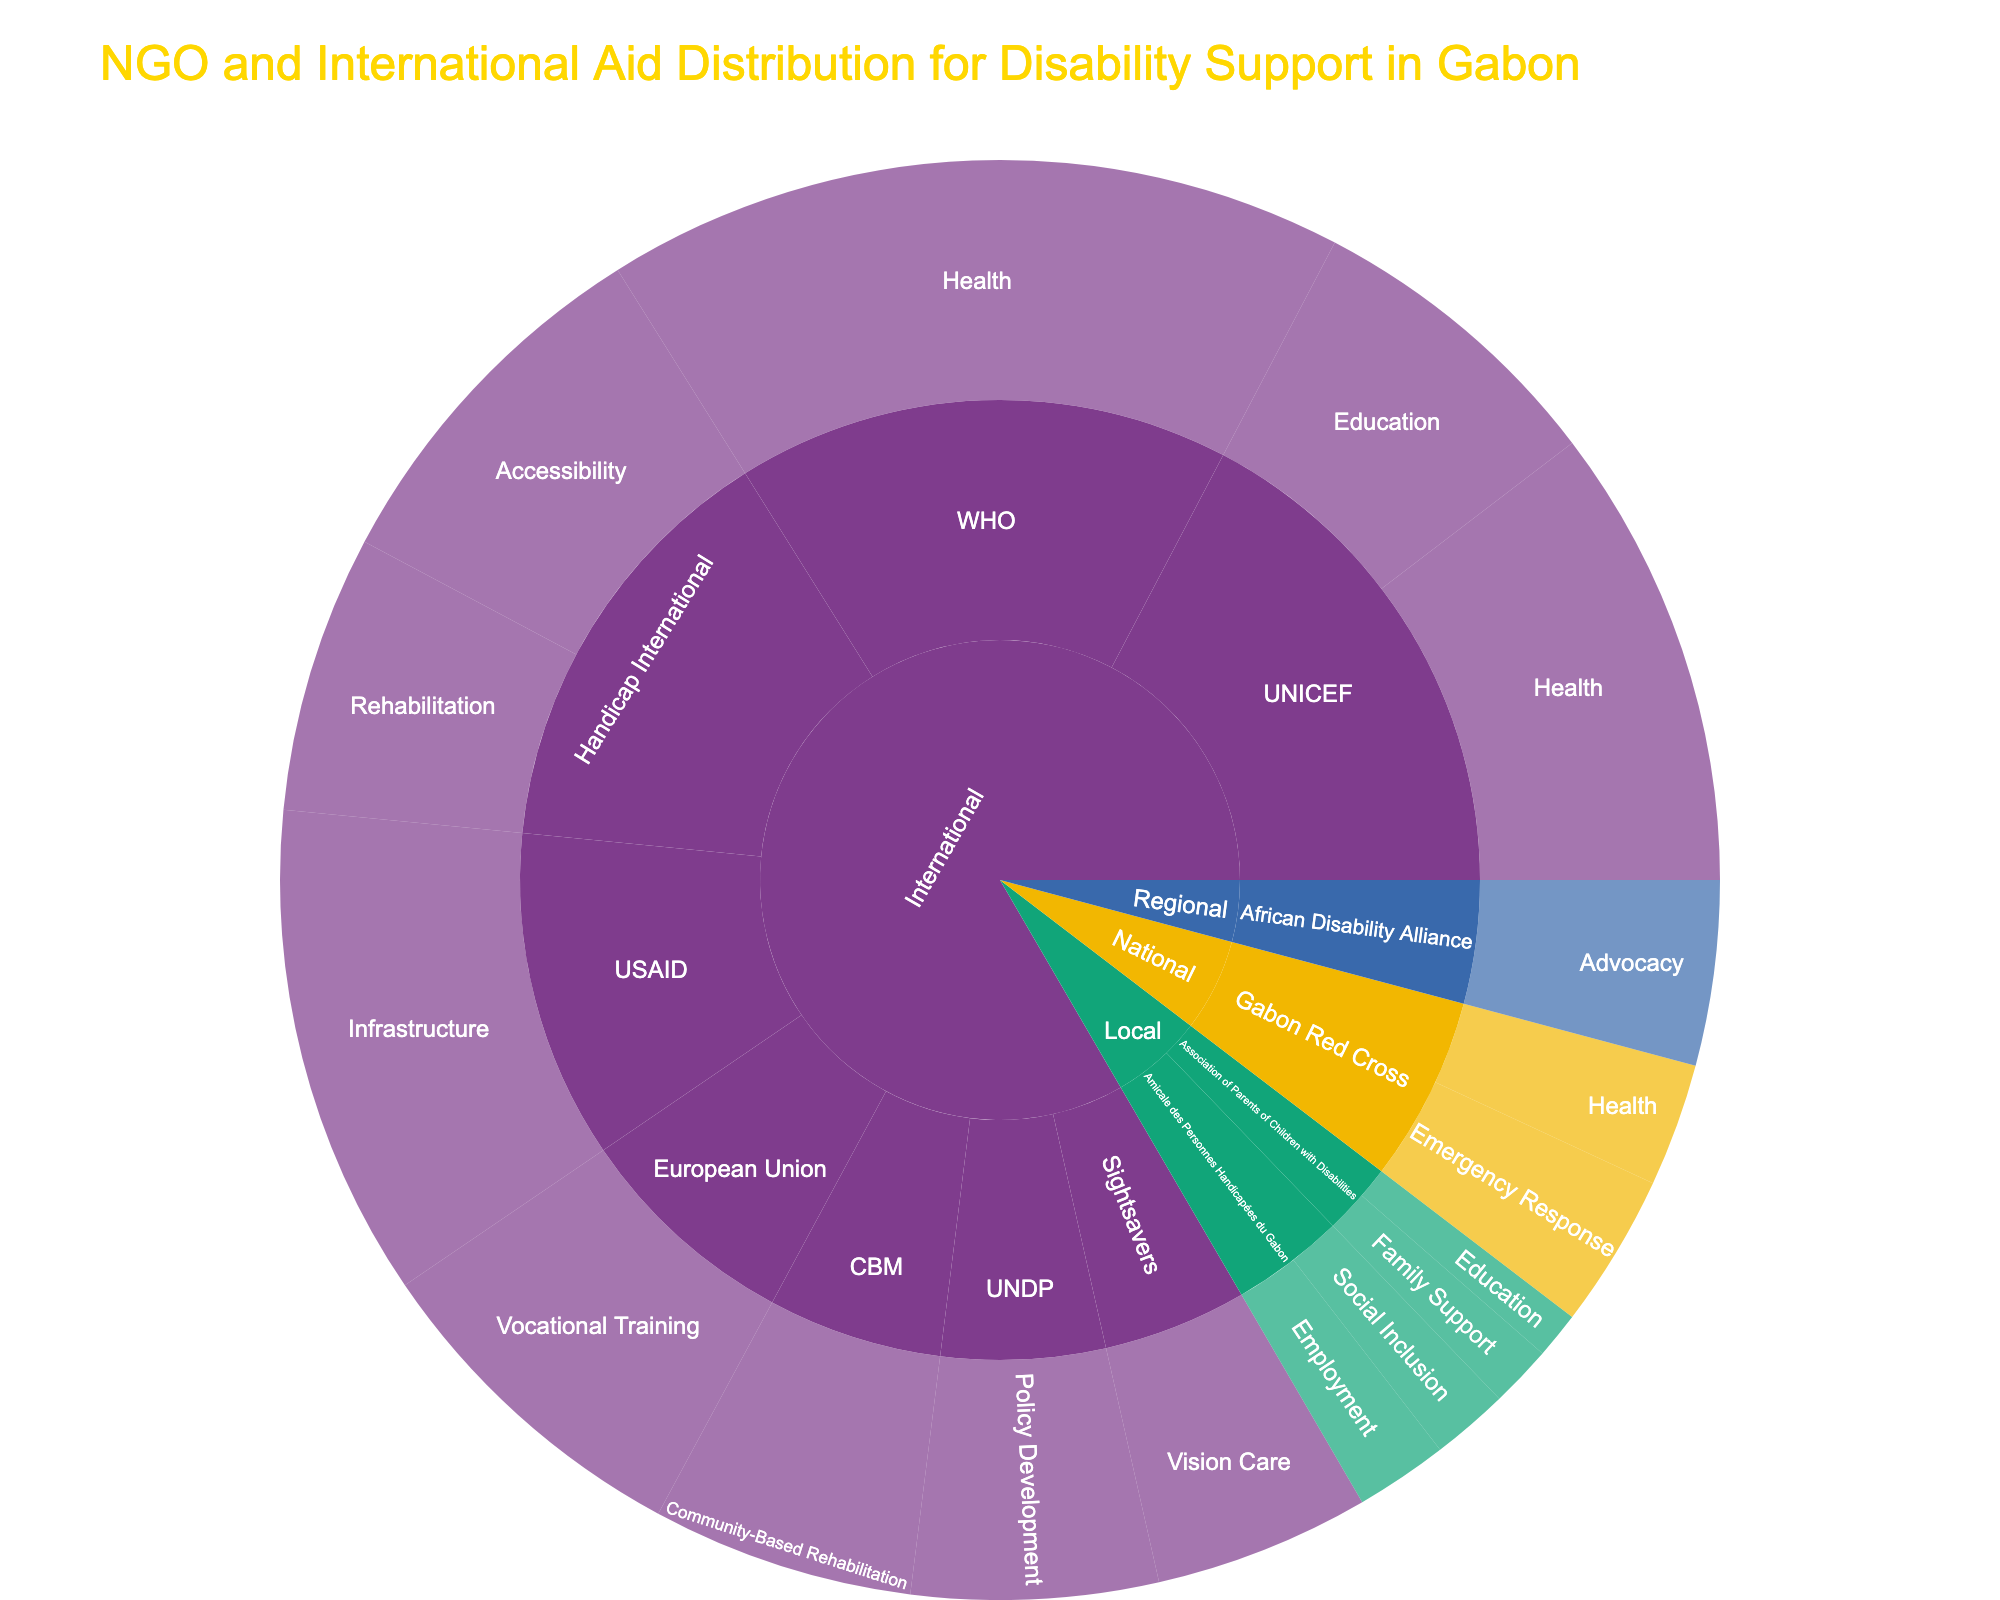How many international organizations are represented in the plot? Count the number of unique labels under the 'International' type section.
Answer: 8 Which organization has the highest funding for health-focused areas? Identify all organizations with a focus area of 'Health' and compare their funding amounts.
Answer: WHO What is the total funding provided by local organizations? Sum the funding amounts for organizations labeled under the 'Local' type.
Answer: 450,000 Which project focus area receives the highest funding? Aggregate the funding amounts for each focus area and compare the totals.
Answer: Health Are there more regional or national organizations represented? Count the number of unique labels under the 'Regional' and 'National' type sections and compare the counts.
Answer: National Which type of organization (International, Regional, National, Local) receives the highest total funding? Sum the funding amounts for each type and compare the totals.
Answer: International What percentage of the total funding does the 'Accessibility' focus area receive? Calculate the total funding for 'Accessibility' and divide by the overall total funding, then multiply by 100.
Answer: 10.4% Is the funding for Education higher at the international level or local level? Compare the sums of the funding for 'Education' under the 'International' and 'Local' sections.
Answer: International Which organization focuses exclusively on 'Advocacy'? Identify the organization(s) with 'Advocacy' as their only focus area.
Answer: African Disability Alliance What is the average funding amount for international organizations? Calculate the total funding for all international organizations and divide by the number of international organizations.
Answer: 681,250 